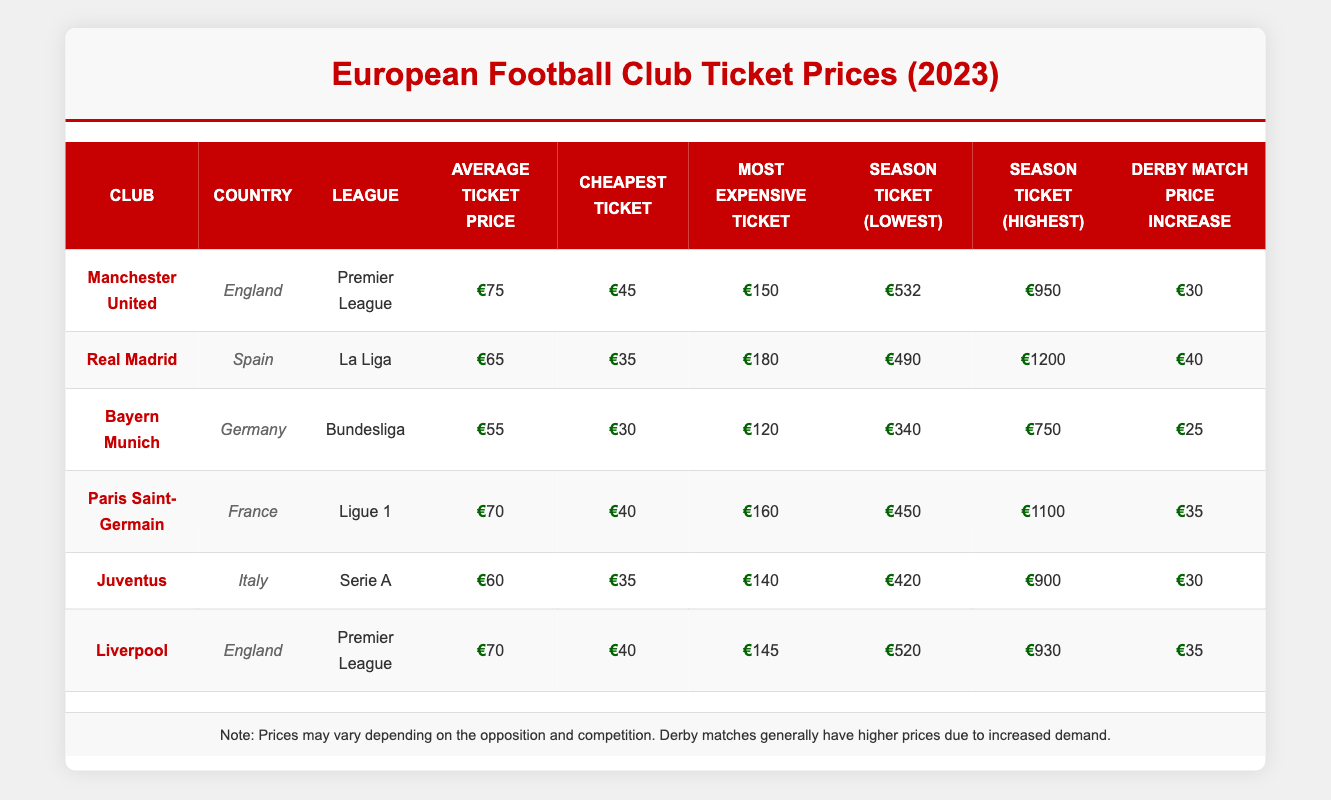What is the average ticket price for Manchester United? The average ticket price for Manchester United is listed in the table under the "Average Ticket Price" column. It shows €75.
Answer: €75 Which club has the highest most expensive ticket price? The "Most Expensive Ticket" column reveals that Real Madrid has the highest price at €180.
Answer: Real Madrid What is the season ticket lowest price for Bayern Munich? The "Season Ticket (Lowest)" column indicates that Bayern Munich has a lowest price of €340.
Answer: €340 Which club has the lowest average ticket price and what is it? By comparing the "Average Ticket Price" values from all clubs, Bayern Munich has the lowest price at €55.
Answer: €55 True or False: The derby match price increase for Liverpool is greater than that of Bayern Munich. By comparing the "Derby Match Price Increase" values, Liverpool has €35 and Bayern Munich has €25, which means Liverpool's increase is indeed greater.
Answer: True What is the total cost difference between the highest and lowest season ticket prices for all clubs? First, we find the "Season Ticket (Highest)" which is €1200 (Real Madrid) and the "Season Ticket (Lowest)" which is €340 (Bayern Munich). The difference is €1200 - €340 = €860.
Answer: €860 How many clubs have an average ticket price higher than €60? By checking the "Average Ticket Price" column, Manchester United (€75), Paris Saint-Germain (€70), and Liverpool (€70) exceed €60, totaling 3 clubs.
Answer: 3 Which country has the club with the lowest cheapest ticket price and what is that price? Checking the "Cheapest Ticket" column, Bayern Munich has the lowest price of €30, representing Germany.
Answer: Germany, €30 What is the average increase in derby match ticket prices across all clubs? To find this, add the derby price increases (30 + 40 + 25 + 35 + 30 + 35 = 225) and divide by the number of clubs (6), resulting in an average of €37.5.
Answer: €37.5 